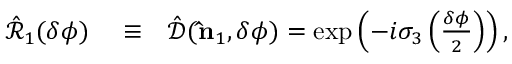Convert formula to latex. <formula><loc_0><loc_0><loc_500><loc_500>\begin{array} { r l r } { \hat { \mathcal { R } } _ { 1 } ( \delta \phi ) } & \equiv } & { \hat { \mathcal { D } } ( { \hat { n } } _ { 1 } , \delta \phi ) = \exp \left ( - i { \sigma } _ { 3 } \left ( \frac { \delta \phi } { 2 } \right ) \right ) , } \end{array}</formula> 